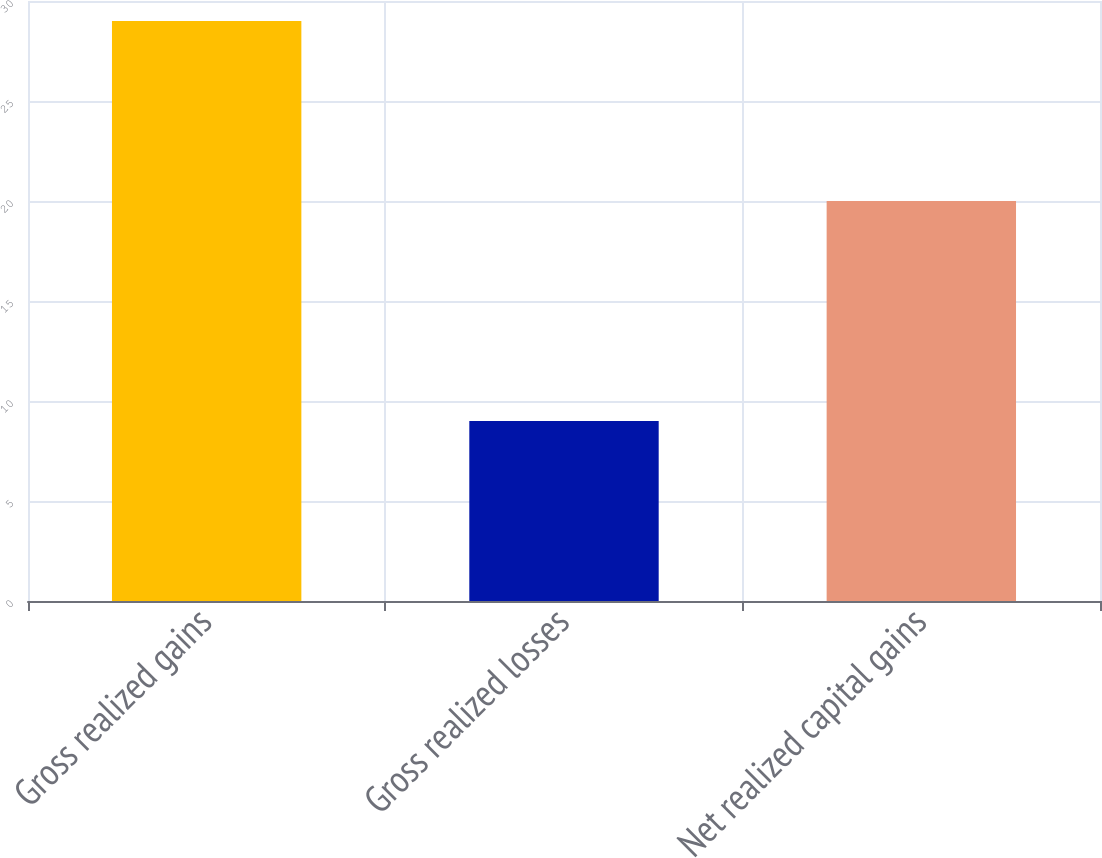Convert chart to OTSL. <chart><loc_0><loc_0><loc_500><loc_500><bar_chart><fcel>Gross realized gains<fcel>Gross realized losses<fcel>Net realized capital gains<nl><fcel>29<fcel>9<fcel>20<nl></chart> 